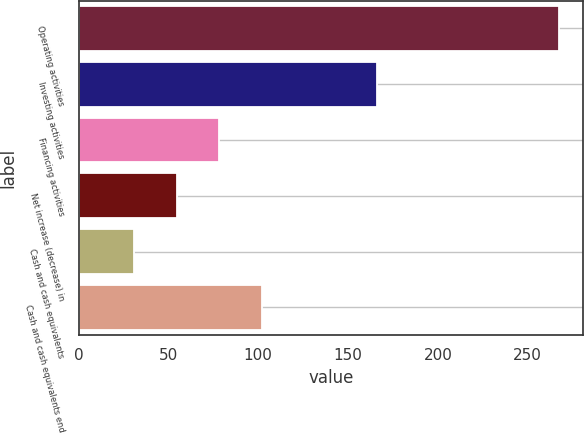Convert chart to OTSL. <chart><loc_0><loc_0><loc_500><loc_500><bar_chart><fcel>Operating activities<fcel>Investing activities<fcel>Financing activities<fcel>Net increase (decrease) in<fcel>Cash and cash equivalents<fcel>Cash and cash equivalents end<nl><fcel>267.5<fcel>166<fcel>78.38<fcel>54.74<fcel>31.1<fcel>102.02<nl></chart> 